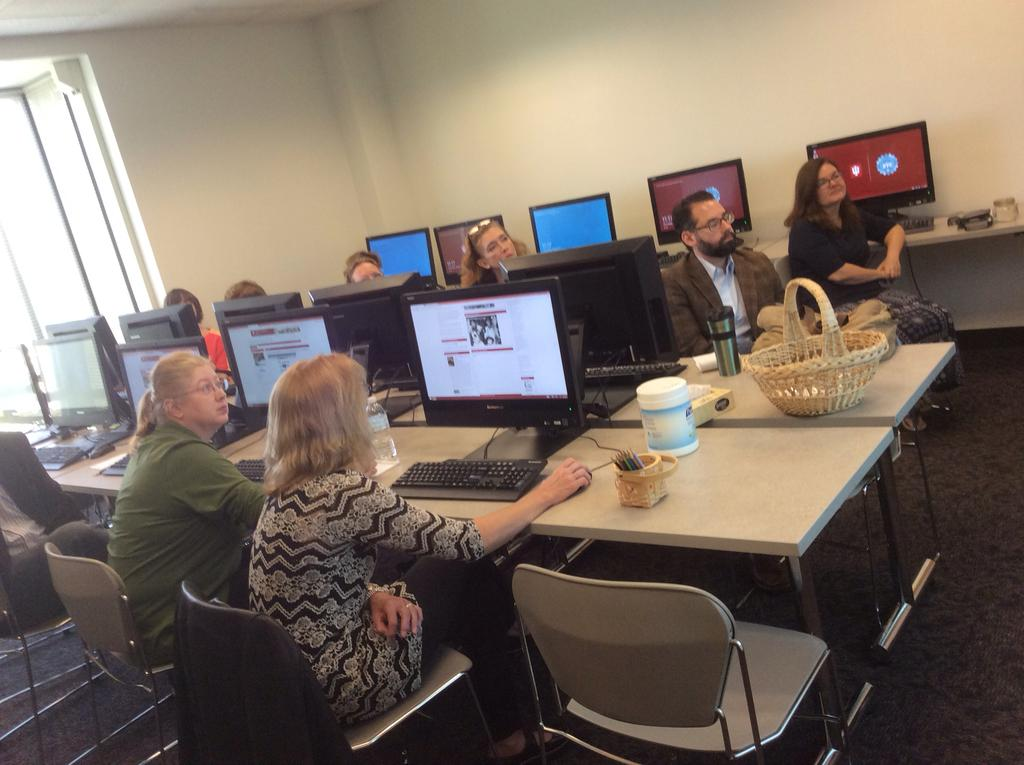What type of objects can be seen in the image? There are electronic gadgets, chairs, a basket, a bottle, and a bench in the image. Are there any people present in the image? Yes, there are people in the image. What type of furniture is visible in the image? There are chairs and a bench in the image. What other object can be seen in the image? There is a wall in the image. What type of competition is taking place in the image? There is no competition present in the image; it features electronic gadgets, chairs, a basket, a bottle, a bench, and people. 